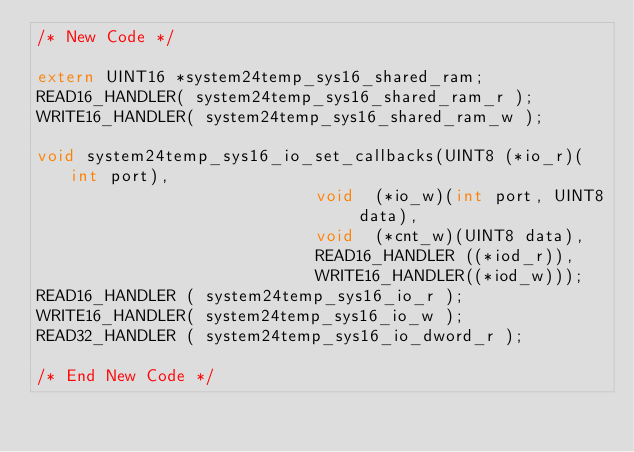<code> <loc_0><loc_0><loc_500><loc_500><_C_>/* New Code */

extern UINT16 *system24temp_sys16_shared_ram;
READ16_HANDLER( system24temp_sys16_shared_ram_r );
WRITE16_HANDLER( system24temp_sys16_shared_ram_w );

void system24temp_sys16_io_set_callbacks(UINT8 (*io_r)(int port),
							void  (*io_w)(int port, UINT8 data),
							void  (*cnt_w)(UINT8 data),
							READ16_HANDLER ((*iod_r)),
							WRITE16_HANDLER((*iod_w)));
READ16_HANDLER ( system24temp_sys16_io_r );
WRITE16_HANDLER( system24temp_sys16_io_w );
READ32_HANDLER ( system24temp_sys16_io_dword_r );

/* End New Code */
</code> 